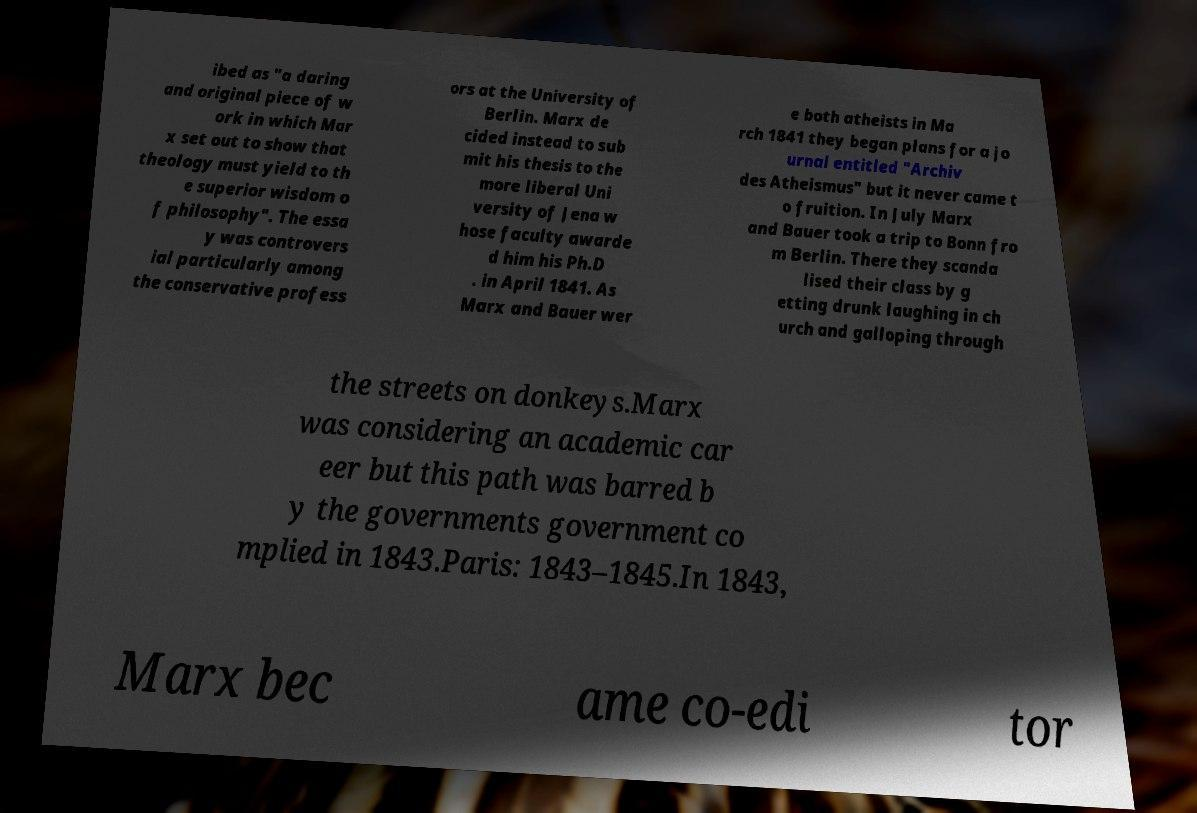There's text embedded in this image that I need extracted. Can you transcribe it verbatim? ibed as "a daring and original piece of w ork in which Mar x set out to show that theology must yield to th e superior wisdom o f philosophy". The essa y was controvers ial particularly among the conservative profess ors at the University of Berlin. Marx de cided instead to sub mit his thesis to the more liberal Uni versity of Jena w hose faculty awarde d him his Ph.D . in April 1841. As Marx and Bauer wer e both atheists in Ma rch 1841 they began plans for a jo urnal entitled "Archiv des Atheismus" but it never came t o fruition. In July Marx and Bauer took a trip to Bonn fro m Berlin. There they scanda lised their class by g etting drunk laughing in ch urch and galloping through the streets on donkeys.Marx was considering an academic car eer but this path was barred b y the governments government co mplied in 1843.Paris: 1843–1845.In 1843, Marx bec ame co-edi tor 